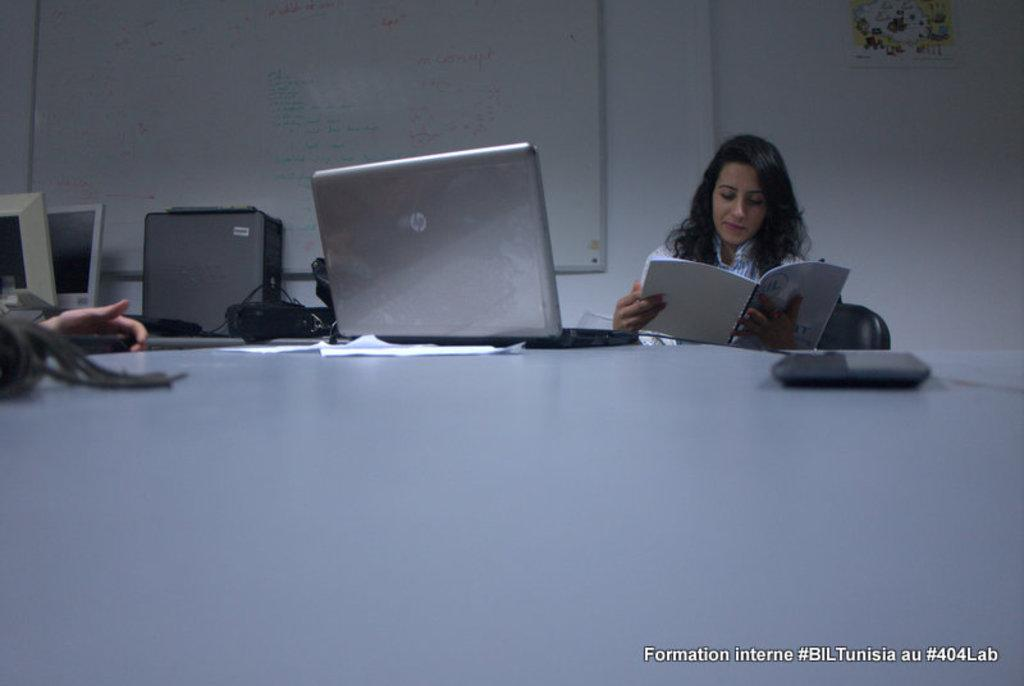What is the main object in the middle of the image? There is a laptop in the middle of the image. Where is the laptop placed? The laptop is on a table. What is the woman in the image doing? The woman is reading a book. Can you describe any additional features of the image? There is a watermark at the bottom of the image. What type of waste can be seen in the image? There is no waste visible in the image. How does the volcano affect the woman in the image? There is no volcano present in the image, so it does not affect the woman. 